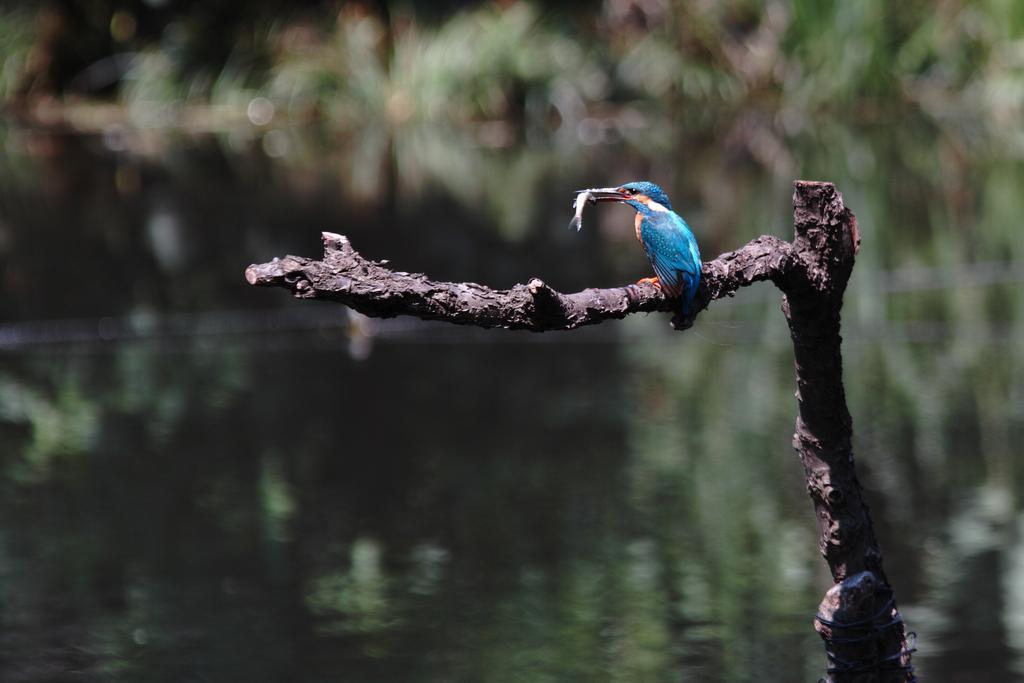Could you give a brief overview of what you see in this image? A bird is holding a fish in its mouth. The bird is present on a tree branch. There is water and the background is blurred. 